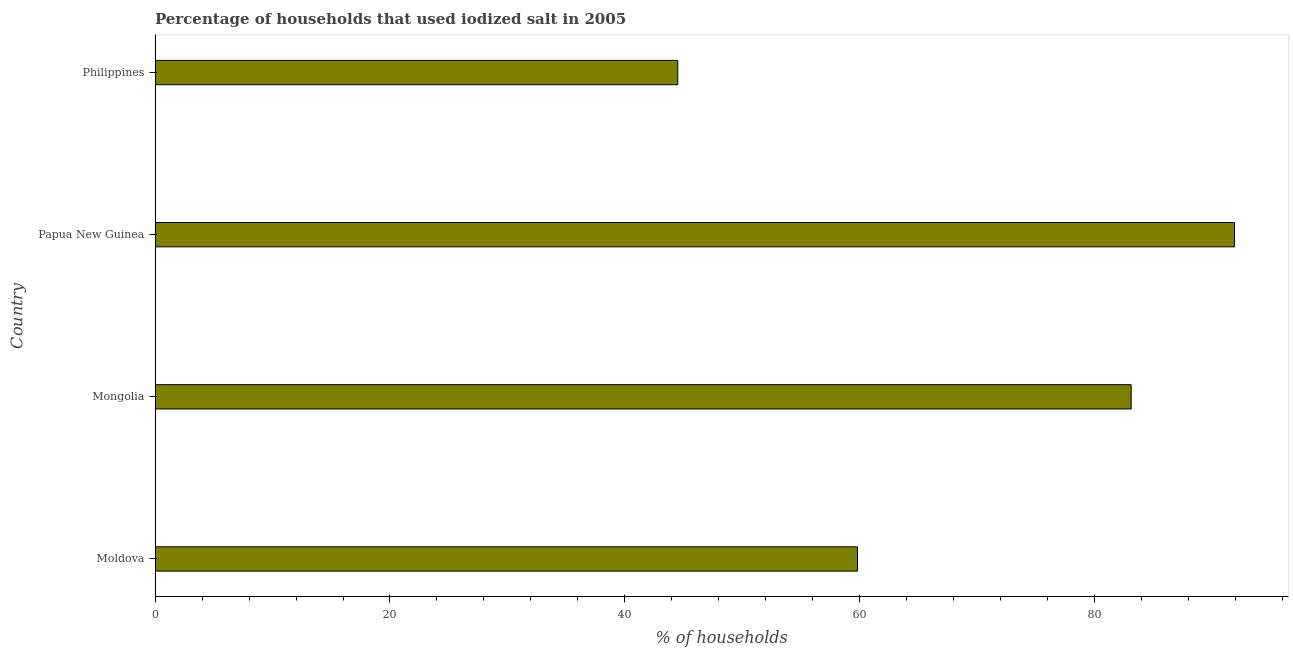Does the graph contain grids?
Make the answer very short. No. What is the title of the graph?
Provide a succinct answer. Percentage of households that used iodized salt in 2005. What is the label or title of the X-axis?
Offer a terse response. % of households. What is the label or title of the Y-axis?
Your response must be concise. Country. What is the percentage of households where iodized salt is consumed in Mongolia?
Keep it short and to the point. 83.1. Across all countries, what is the maximum percentage of households where iodized salt is consumed?
Keep it short and to the point. 91.9. Across all countries, what is the minimum percentage of households where iodized salt is consumed?
Your response must be concise. 44.5. In which country was the percentage of households where iodized salt is consumed maximum?
Offer a terse response. Papua New Guinea. In which country was the percentage of households where iodized salt is consumed minimum?
Provide a short and direct response. Philippines. What is the sum of the percentage of households where iodized salt is consumed?
Make the answer very short. 279.3. What is the average percentage of households where iodized salt is consumed per country?
Ensure brevity in your answer.  69.83. What is the median percentage of households where iodized salt is consumed?
Your answer should be compact. 71.45. In how many countries, is the percentage of households where iodized salt is consumed greater than 40 %?
Provide a short and direct response. 4. What is the ratio of the percentage of households where iodized salt is consumed in Moldova to that in Papua New Guinea?
Offer a terse response. 0.65. Is the percentage of households where iodized salt is consumed in Moldova less than that in Mongolia?
Keep it short and to the point. Yes. Is the difference between the percentage of households where iodized salt is consumed in Mongolia and Philippines greater than the difference between any two countries?
Provide a succinct answer. No. What is the difference between the highest and the second highest percentage of households where iodized salt is consumed?
Your response must be concise. 8.8. What is the difference between the highest and the lowest percentage of households where iodized salt is consumed?
Your response must be concise. 47.4. Are the values on the major ticks of X-axis written in scientific E-notation?
Offer a very short reply. No. What is the % of households of Moldova?
Provide a short and direct response. 59.8. What is the % of households of Mongolia?
Give a very brief answer. 83.1. What is the % of households of Papua New Guinea?
Make the answer very short. 91.9. What is the % of households of Philippines?
Offer a terse response. 44.5. What is the difference between the % of households in Moldova and Mongolia?
Offer a very short reply. -23.3. What is the difference between the % of households in Moldova and Papua New Guinea?
Your response must be concise. -32.1. What is the difference between the % of households in Moldova and Philippines?
Make the answer very short. 15.3. What is the difference between the % of households in Mongolia and Papua New Guinea?
Offer a terse response. -8.8. What is the difference between the % of households in Mongolia and Philippines?
Provide a succinct answer. 38.6. What is the difference between the % of households in Papua New Guinea and Philippines?
Keep it short and to the point. 47.4. What is the ratio of the % of households in Moldova to that in Mongolia?
Your response must be concise. 0.72. What is the ratio of the % of households in Moldova to that in Papua New Guinea?
Provide a succinct answer. 0.65. What is the ratio of the % of households in Moldova to that in Philippines?
Keep it short and to the point. 1.34. What is the ratio of the % of households in Mongolia to that in Papua New Guinea?
Provide a succinct answer. 0.9. What is the ratio of the % of households in Mongolia to that in Philippines?
Provide a short and direct response. 1.87. What is the ratio of the % of households in Papua New Guinea to that in Philippines?
Ensure brevity in your answer.  2.06. 